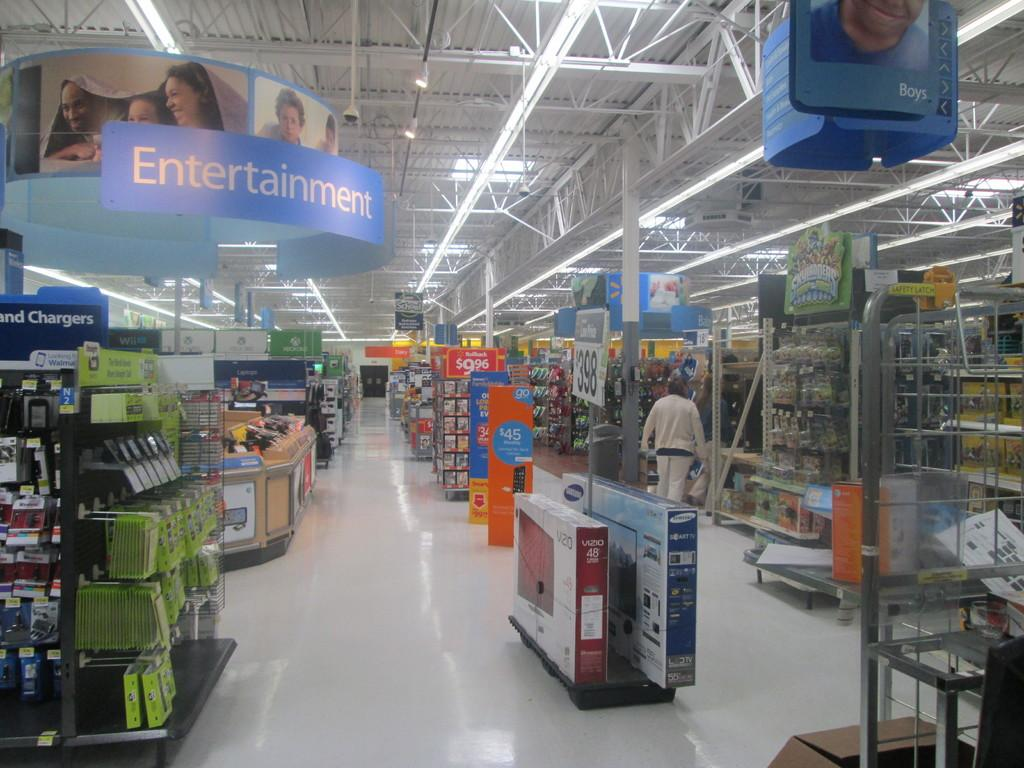Provide a one-sentence caption for the provided image. A large sign hangs above the Entertainment section. 